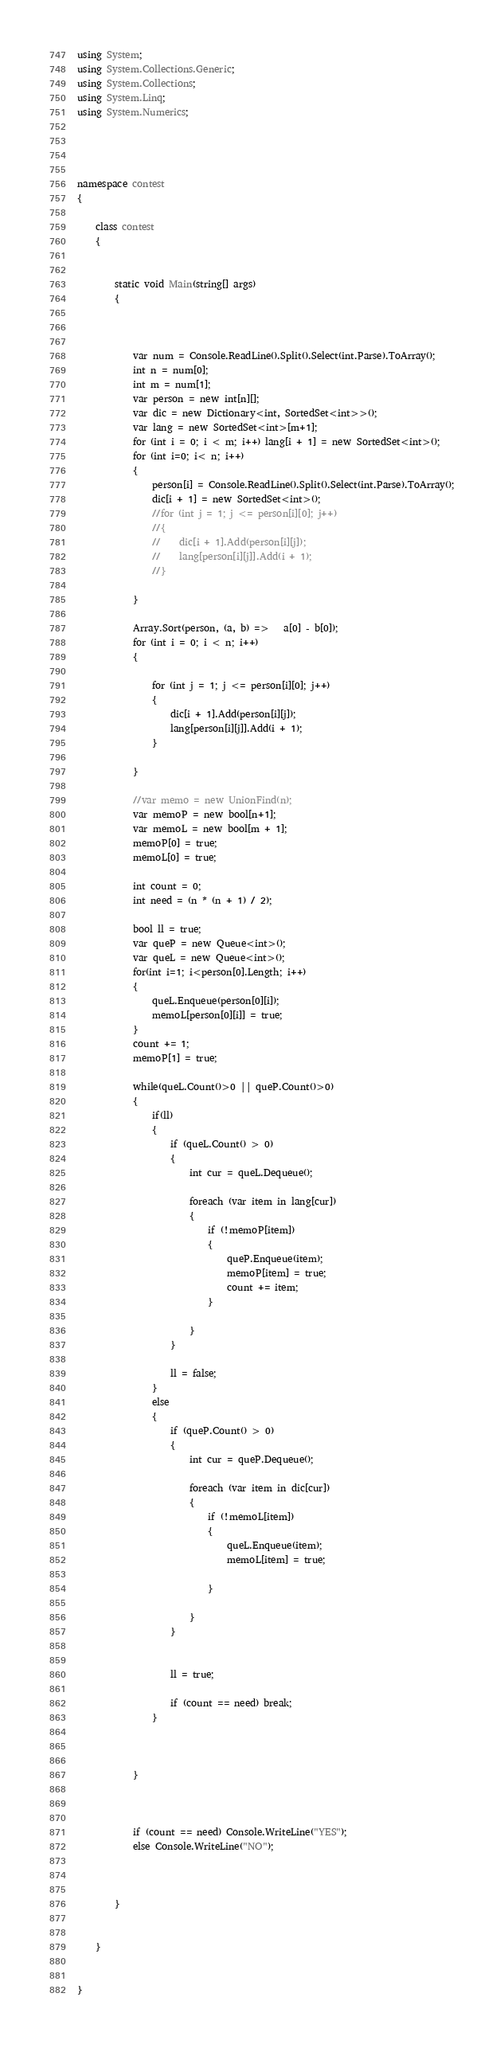<code> <loc_0><loc_0><loc_500><loc_500><_C#_>using System;
using System.Collections.Generic;
using System.Collections;
using System.Linq;
using System.Numerics;




namespace contest
{

    class contest
    {


        static void Main(string[] args)
        {


            
            var num = Console.ReadLine().Split().Select(int.Parse).ToArray();
            int n = num[0];
            int m = num[1];
            var person = new int[n][];
            var dic = new Dictionary<int, SortedSet<int>>();
            var lang = new SortedSet<int>[m+1];
            for (int i = 0; i < m; i++) lang[i + 1] = new SortedSet<int>();
            for (int i=0; i< n; i++)
            {
                person[i] = Console.ReadLine().Split().Select(int.Parse).ToArray();
                dic[i + 1] = new SortedSet<int>();
                //for (int j = 1; j <= person[i][0]; j++)
                //{
                //    dic[i + 1].Add(person[i][j]);
                //    lang[person[i][j]].Add(i + 1);
                //}

            }

            Array.Sort(person, (a, b) =>   a[0] - b[0]);
            for (int i = 0; i < n; i++)
            {
               
                for (int j = 1; j <= person[i][0]; j++)
                {
                    dic[i + 1].Add(person[i][j]);
                    lang[person[i][j]].Add(i + 1);
                }

            }

            //var memo = new UnionFind(n);
            var memoP = new bool[n+1];
            var memoL = new bool[m + 1];
            memoP[0] = true;
            memoL[0] = true;

            int count = 0;
            int need = (n * (n + 1) / 2);

            bool ll = true;
            var queP = new Queue<int>();
            var queL = new Queue<int>();
            for(int i=1; i<person[0].Length; i++)
            {
                queL.Enqueue(person[0][i]);
                memoL[person[0][i]] = true;
            }
            count += 1;
            memoP[1] = true;

            while(queL.Count()>0 || queP.Count()>0)
            {
                if(ll)
                {
                    if (queL.Count() > 0)
                    {
                        int cur = queL.Dequeue();

                        foreach (var item in lang[cur])
                        {
                            if (!memoP[item])
                            {
                                queP.Enqueue(item);
                                memoP[item] = true;
                                count += item;
                            }

                        }
                    }

                    ll = false;
                }
                else
                {
                    if (queP.Count() > 0)
                    {
                        int cur = queP.Dequeue();

                        foreach (var item in dic[cur])
                        {
                            if (!memoL[item])
                            {
                                queL.Enqueue(item);
                                memoL[item] = true;

                            }

                        }
                    }


                    ll = true;

                    if (count == need) break;
                }

               

            }



            if (count == need) Console.WriteLine("YES");
            else Console.WriteLine("NO");
           
			
           
        }

      
    }

   
}


</code> 